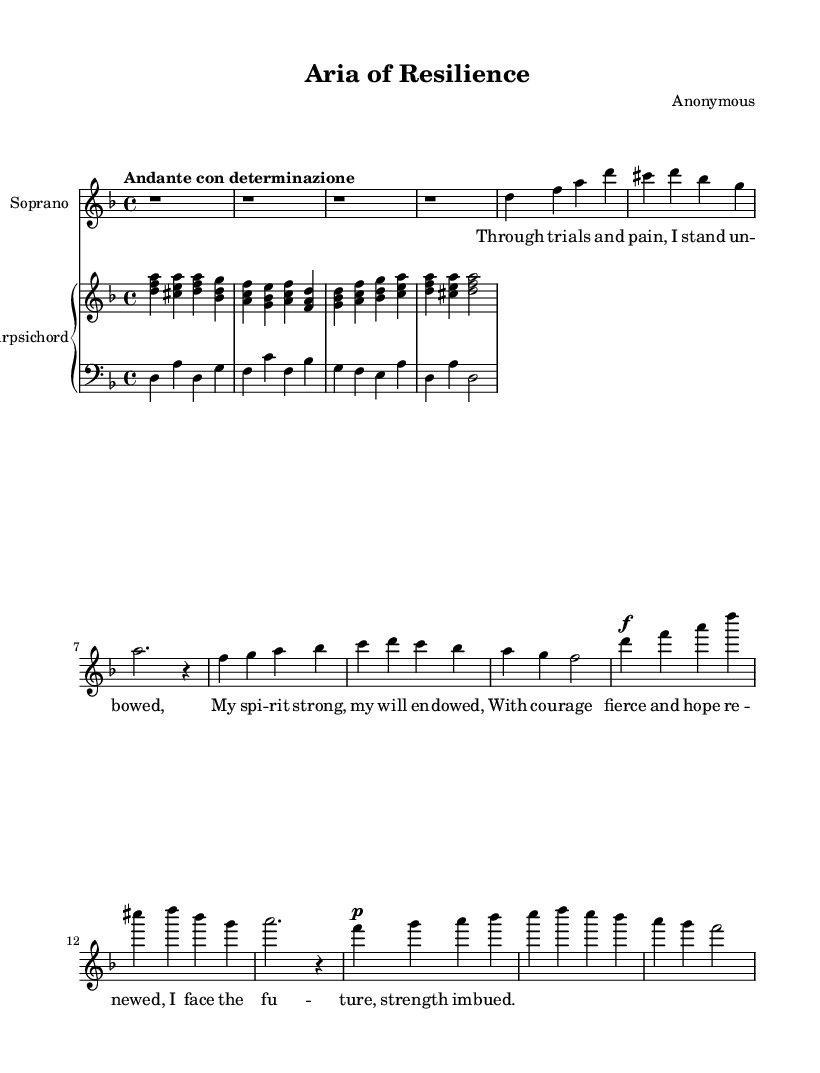What is the key signature of this music? The key signature is indicated by the number of sharps or flats at the beginning of the staff. In this case, there are no sharps or flats shown, meaning it is in the key of D minor.
Answer: D minor What is the time signature of this piece? The time signature is found at the beginning of the staff after the key signature. Here, it is written as a fraction: 4/4, indicating four beats per measure.
Answer: 4/4 What is the tempo marking of this aria? The tempo marking is located at the beginning of the score, written as "Andante con determinazione," which indicates a moderate tempo with determination.
Answer: Andante con determinazione How many measures are in the soprano part? To find the number of measures in the soprano part, count the number of vertical lines indicating the end of each measure in the music. There are a total of 8 measures.
Answer: 8 What is the dynamic marking at the beginning of the soprano part? The dynamic marking can be found at the beginning of the soprano line, which is marked as "f," indicating that this section should be played forte or loudly.
Answer: f Which vocal range does this piece feature? The vocal range is indicated by the clef used. The soprano part is written in a treble clef, which is specifically for higher female voices.
Answer: Soprano Which instrument accompanies the soprano part? The accompanying instrument is indicated in the score. The piano staff below the soprano part, labeled as "Harpsichord," shows that it accompanies the vocals.
Answer: Harpsichord 